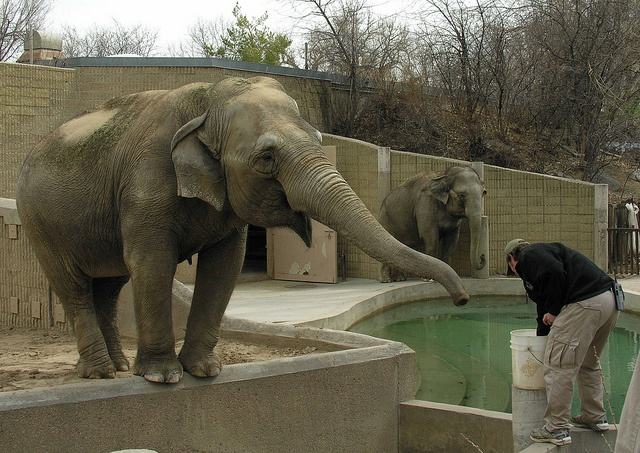Describe the objects in this image and their specific colors. I can see elephant in lavender, black, darkgreen, and gray tones, people in lavender, black, and gray tones, and elephant in lavender, black, darkgreen, and gray tones in this image. 